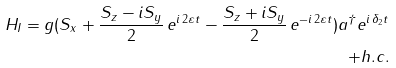Convert formula to latex. <formula><loc_0><loc_0><loc_500><loc_500>H _ { I } = g ( S _ { x } + \frac { S _ { z } - i S _ { y } } { 2 } \, e ^ { i \, 2 \varepsilon t } - \frac { S _ { z } + i S _ { y } } { 2 } \, e ^ { - i \, 2 \varepsilon t } ) a ^ { \dagger } e ^ { i \, \delta _ { 2 } t } \\ + h . c .</formula> 